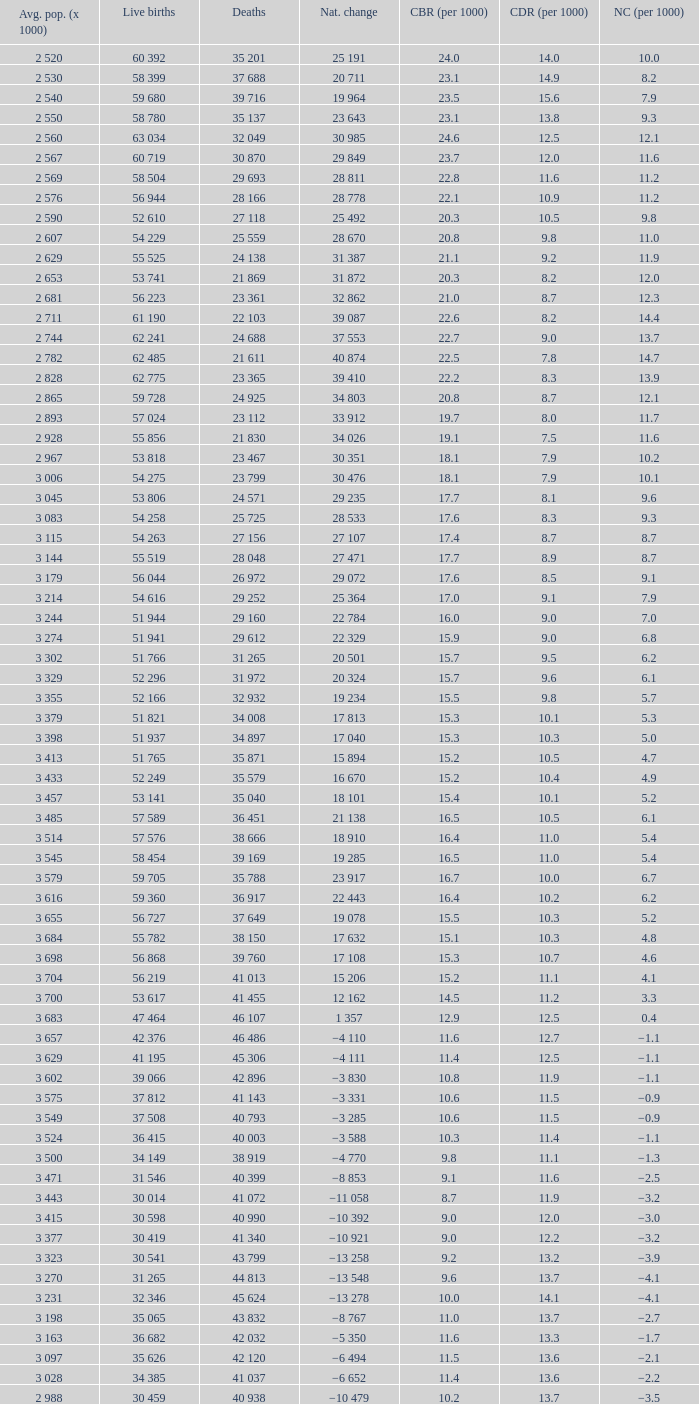Which Average population (x 1000) has a Crude death rate (per 1000) smaller than 10.9, and a Crude birth rate (per 1000) smaller than 19.7, and a Natural change (per 1000) of 8.7, and Live births of 54 263? 3 115. 